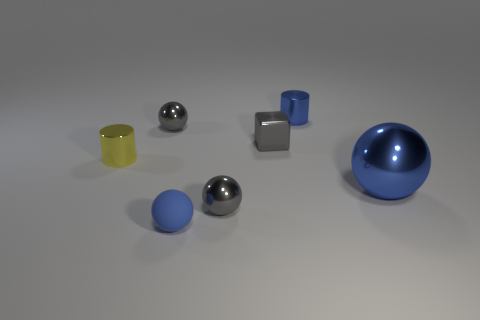There is a yellow metallic thing; what shape is it?
Provide a succinct answer. Cylinder. There is a thing that is both right of the tiny metallic block and in front of the small yellow thing; what is its size?
Ensure brevity in your answer.  Large. There is a gray sphere in front of the small yellow thing; what material is it?
Provide a short and direct response. Metal. Do the big metal object and the tiny cylinder to the right of the rubber sphere have the same color?
Your response must be concise. Yes. What number of objects are either blue objects left of the tiny blue cylinder or small things on the left side of the small blue metallic cylinder?
Ensure brevity in your answer.  5. There is a tiny shiny object that is in front of the gray shiny block and right of the small yellow cylinder; what is its color?
Make the answer very short. Gray. Is the number of tiny gray balls greater than the number of tiny gray blocks?
Keep it short and to the point. Yes. Do the blue thing to the left of the gray shiny cube and the large blue object have the same shape?
Your response must be concise. Yes. What number of shiny things are either balls or small yellow objects?
Provide a succinct answer. 4. Are there any cylinders that have the same material as the big blue object?
Ensure brevity in your answer.  Yes. 